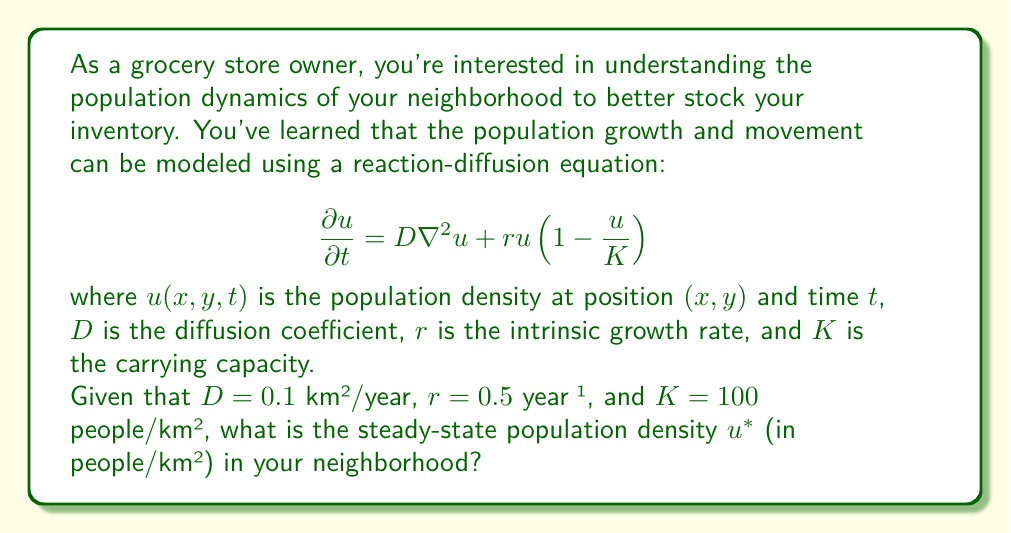Solve this math problem. To solve this problem, we need to understand the concept of steady-state in a reaction-diffusion equation. At steady-state, the population density doesn't change with time, so $\frac{\partial u}{\partial t} = 0$.

Let's approach this step-by-step:

1) At steady-state, the equation becomes:

   $$0 = D\nabla^2u^* + ru^*(1-\frac{u^*}{K})$$

2) In a homogeneous environment at steady-state, we can assume that the population density is uniform across space. This means that $\nabla^2u^* = 0$.

3) With this assumption, our equation simplifies to:

   $$0 = ru^*(1-\frac{u^*}{K})$$

4) This equation has two solutions:
   
   a) $u^* = 0$ (trivial solution)
   b) $1-\frac{u^*}{K} = 0$

5) The non-trivial solution (b) gives us:

   $$1-\frac{u^*}{K} = 0$$
   $$-\frac{u^*}{K} = -1$$
   $$u^* = K$$

6) Therefore, the steady-state population density is equal to the carrying capacity $K$.

7) We're given that $K = 100$ people/km².

Note that this solution is independent of $D$ and $r$. These parameters affect how quickly the population approaches the steady-state, but not the steady-state value itself in a homogeneous environment.
Answer: The steady-state population density $u^*$ is 100 people/km². 